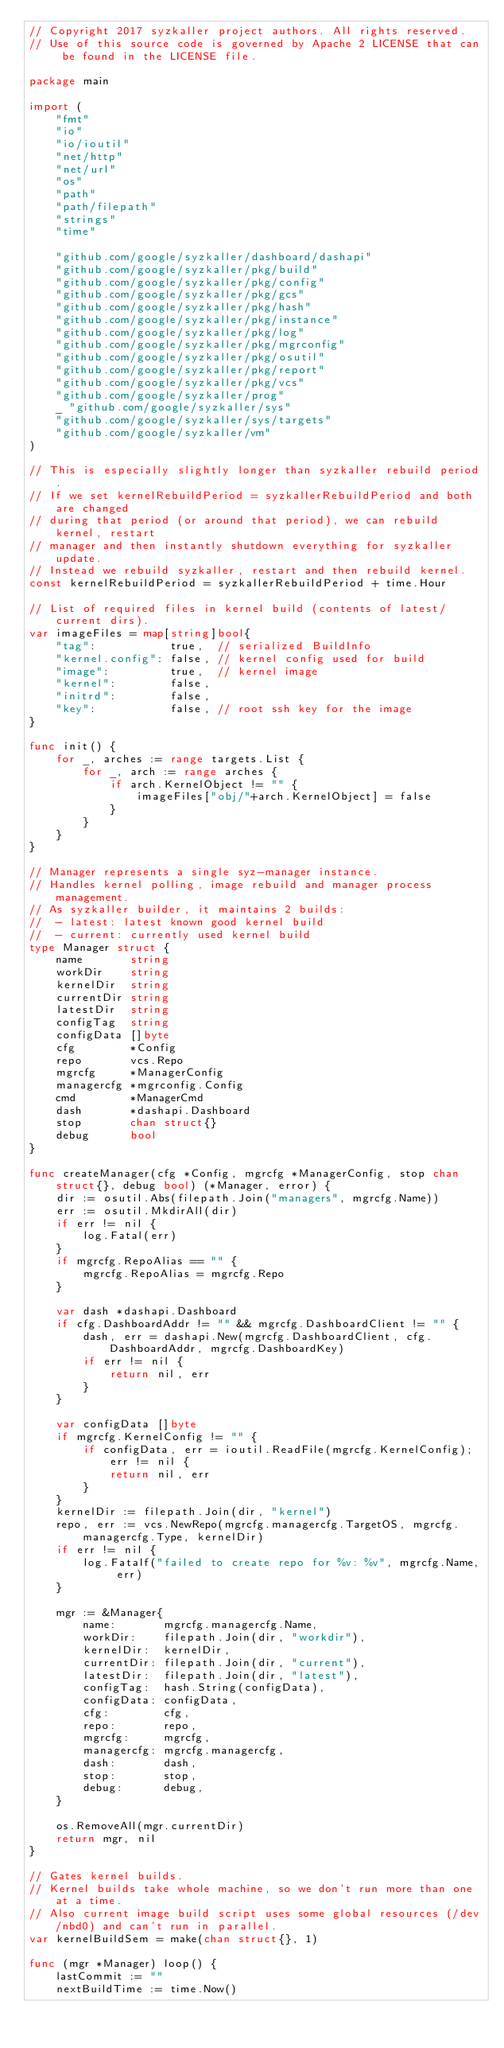<code> <loc_0><loc_0><loc_500><loc_500><_Go_>// Copyright 2017 syzkaller project authors. All rights reserved.
// Use of this source code is governed by Apache 2 LICENSE that can be found in the LICENSE file.

package main

import (
	"fmt"
	"io"
	"io/ioutil"
	"net/http"
	"net/url"
	"os"
	"path"
	"path/filepath"
	"strings"
	"time"

	"github.com/google/syzkaller/dashboard/dashapi"
	"github.com/google/syzkaller/pkg/build"
	"github.com/google/syzkaller/pkg/config"
	"github.com/google/syzkaller/pkg/gcs"
	"github.com/google/syzkaller/pkg/hash"
	"github.com/google/syzkaller/pkg/instance"
	"github.com/google/syzkaller/pkg/log"
	"github.com/google/syzkaller/pkg/mgrconfig"
	"github.com/google/syzkaller/pkg/osutil"
	"github.com/google/syzkaller/pkg/report"
	"github.com/google/syzkaller/pkg/vcs"
	"github.com/google/syzkaller/prog"
	_ "github.com/google/syzkaller/sys"
	"github.com/google/syzkaller/sys/targets"
	"github.com/google/syzkaller/vm"
)

// This is especially slightly longer than syzkaller rebuild period.
// If we set kernelRebuildPeriod = syzkallerRebuildPeriod and both are changed
// during that period (or around that period), we can rebuild kernel, restart
// manager and then instantly shutdown everything for syzkaller update.
// Instead we rebuild syzkaller, restart and then rebuild kernel.
const kernelRebuildPeriod = syzkallerRebuildPeriod + time.Hour

// List of required files in kernel build (contents of latest/current dirs).
var imageFiles = map[string]bool{
	"tag":           true,  // serialized BuildInfo
	"kernel.config": false, // kernel config used for build
	"image":         true,  // kernel image
	"kernel":        false,
	"initrd":        false,
	"key":           false, // root ssh key for the image
}

func init() {
	for _, arches := range targets.List {
		for _, arch := range arches {
			if arch.KernelObject != "" {
				imageFiles["obj/"+arch.KernelObject] = false
			}
		}
	}
}

// Manager represents a single syz-manager instance.
// Handles kernel polling, image rebuild and manager process management.
// As syzkaller builder, it maintains 2 builds:
//  - latest: latest known good kernel build
//  - current: currently used kernel build
type Manager struct {
	name       string
	workDir    string
	kernelDir  string
	currentDir string
	latestDir  string
	configTag  string
	configData []byte
	cfg        *Config
	repo       vcs.Repo
	mgrcfg     *ManagerConfig
	managercfg *mgrconfig.Config
	cmd        *ManagerCmd
	dash       *dashapi.Dashboard
	stop       chan struct{}
	debug      bool
}

func createManager(cfg *Config, mgrcfg *ManagerConfig, stop chan struct{}, debug bool) (*Manager, error) {
	dir := osutil.Abs(filepath.Join("managers", mgrcfg.Name))
	err := osutil.MkdirAll(dir)
	if err != nil {
		log.Fatal(err)
	}
	if mgrcfg.RepoAlias == "" {
		mgrcfg.RepoAlias = mgrcfg.Repo
	}

	var dash *dashapi.Dashboard
	if cfg.DashboardAddr != "" && mgrcfg.DashboardClient != "" {
		dash, err = dashapi.New(mgrcfg.DashboardClient, cfg.DashboardAddr, mgrcfg.DashboardKey)
		if err != nil {
			return nil, err
		}
	}

	var configData []byte
	if mgrcfg.KernelConfig != "" {
		if configData, err = ioutil.ReadFile(mgrcfg.KernelConfig); err != nil {
			return nil, err
		}
	}
	kernelDir := filepath.Join(dir, "kernel")
	repo, err := vcs.NewRepo(mgrcfg.managercfg.TargetOS, mgrcfg.managercfg.Type, kernelDir)
	if err != nil {
		log.Fatalf("failed to create repo for %v: %v", mgrcfg.Name, err)
	}

	mgr := &Manager{
		name:       mgrcfg.managercfg.Name,
		workDir:    filepath.Join(dir, "workdir"),
		kernelDir:  kernelDir,
		currentDir: filepath.Join(dir, "current"),
		latestDir:  filepath.Join(dir, "latest"),
		configTag:  hash.String(configData),
		configData: configData,
		cfg:        cfg,
		repo:       repo,
		mgrcfg:     mgrcfg,
		managercfg: mgrcfg.managercfg,
		dash:       dash,
		stop:       stop,
		debug:      debug,
	}

	os.RemoveAll(mgr.currentDir)
	return mgr, nil
}

// Gates kernel builds.
// Kernel builds take whole machine, so we don't run more than one at a time.
// Also current image build script uses some global resources (/dev/nbd0) and can't run in parallel.
var kernelBuildSem = make(chan struct{}, 1)

func (mgr *Manager) loop() {
	lastCommit := ""
	nextBuildTime := time.Now()</code> 